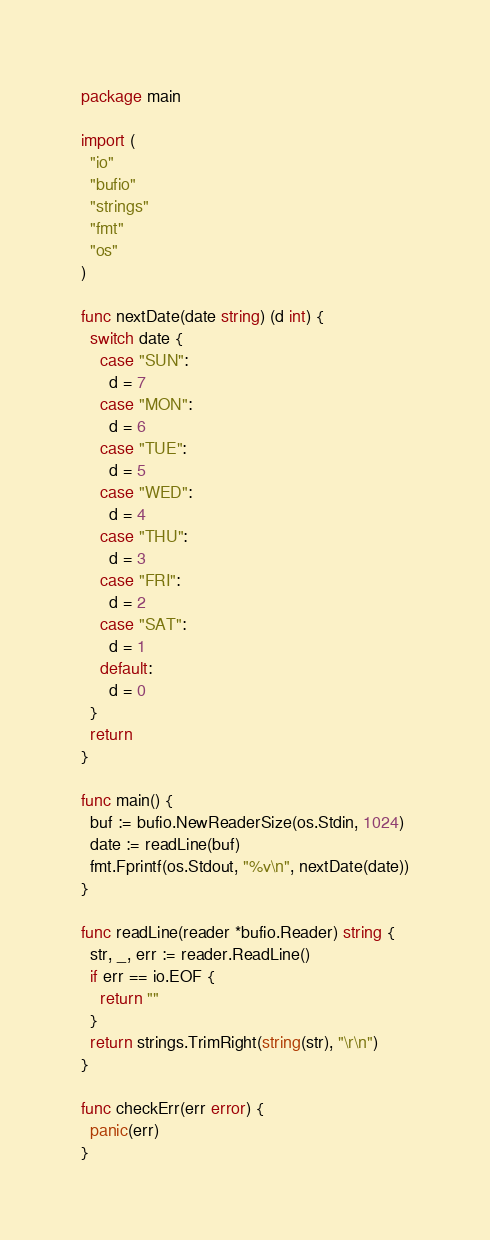<code> <loc_0><loc_0><loc_500><loc_500><_Go_>package main

import (
  "io"
  "bufio"
  "strings"
  "fmt"
  "os"
)
 
func nextDate(date string) (d int) {
  switch date {
    case "SUN":
      d = 7
    case "MON":
      d = 6
    case "TUE":
      d = 5
    case "WED":
      d = 4
    case "THU":
      d = 3
    case "FRI":
      d = 2
    case "SAT":
      d = 1
    default:
      d = 0
  }
  return
}
 
func main() {
  buf := bufio.NewReaderSize(os.Stdin, 1024)
  date := readLine(buf)
  fmt.Fprintf(os.Stdout, "%v\n", nextDate(date))
}
 
func readLine(reader *bufio.Reader) string {
  str, _, err := reader.ReadLine()
  if err == io.EOF {
    return ""
  }
  return strings.TrimRight(string(str), "\r\n")
}
 
func checkErr(err error) {
  panic(err)
}

</code> 